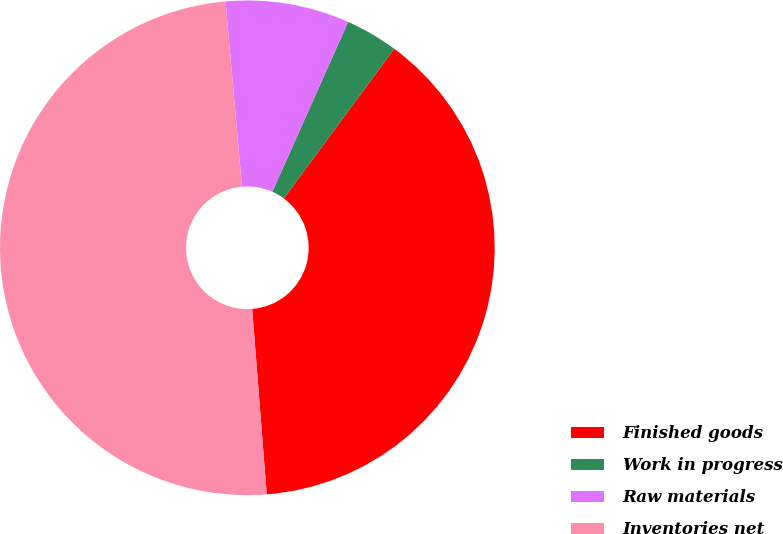<chart> <loc_0><loc_0><loc_500><loc_500><pie_chart><fcel>Finished goods<fcel>Work in progress<fcel>Raw materials<fcel>Inventories net<nl><fcel>38.63%<fcel>3.44%<fcel>8.08%<fcel>49.84%<nl></chart> 